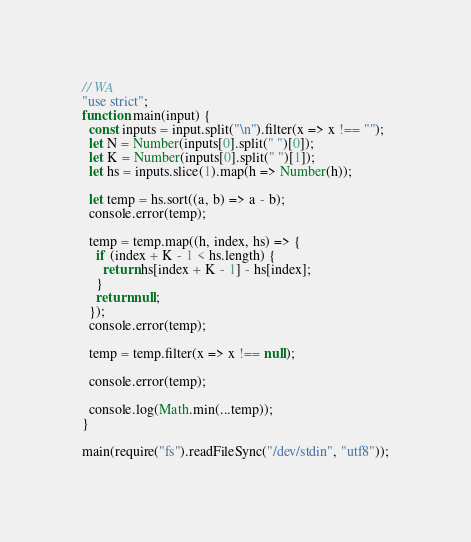<code> <loc_0><loc_0><loc_500><loc_500><_JavaScript_>// WA
"use strict";
function main(input) {
  const inputs = input.split("\n").filter(x => x !== "");
  let N = Number(inputs[0].split(" ")[0]);
  let K = Number(inputs[0].split(" ")[1]);
  let hs = inputs.slice(1).map(h => Number(h));

  let temp = hs.sort((a, b) => a - b);
  console.error(temp);

  temp = temp.map((h, index, hs) => {
    if (index + K - 1 < hs.length) {
      return hs[index + K - 1] - hs[index];
    }
    return null;
  });
  console.error(temp);

  temp = temp.filter(x => x !== null);

  console.error(temp);

  console.log(Math.min(...temp));
}

main(require("fs").readFileSync("/dev/stdin", "utf8"));
</code> 